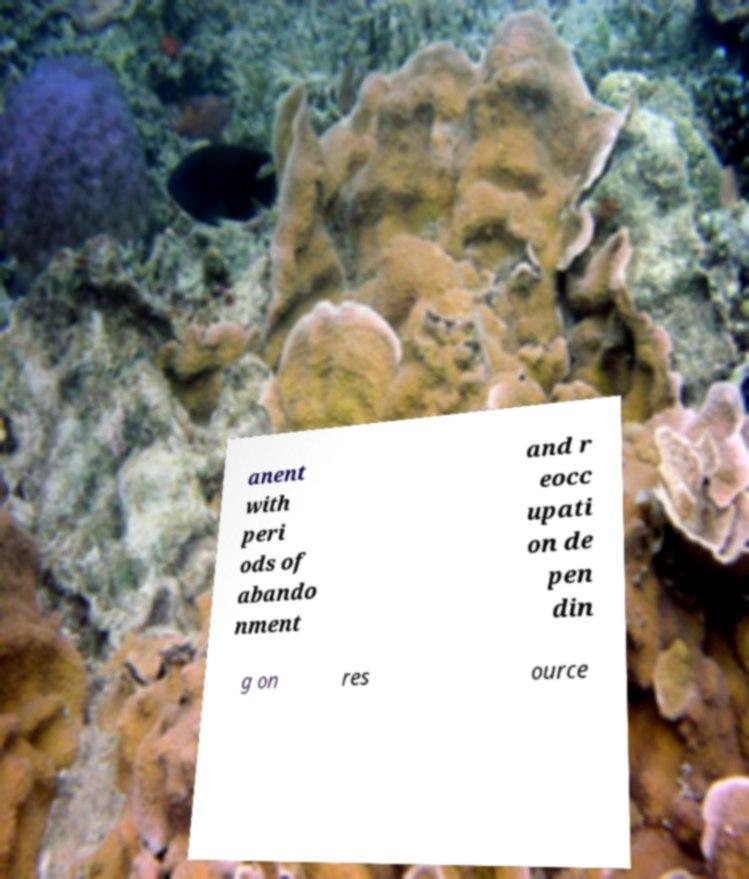Can you read and provide the text displayed in the image?This photo seems to have some interesting text. Can you extract and type it out for me? anent with peri ods of abando nment and r eocc upati on de pen din g on res ource 